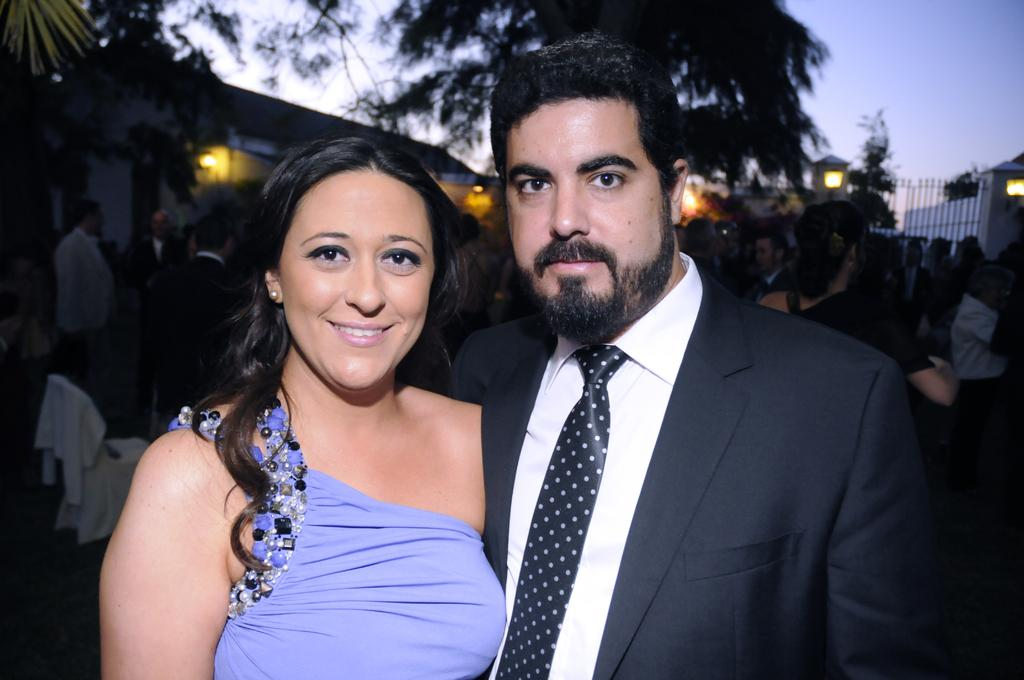Who is present in the image? There is a man and a woman in the image. What is the woman doing in the image? The woman is posing for a camera. What is the woman's facial expression in the image? The woman is smiling in the image. What can be seen in the background of the image? There is a group of people, lights, trees, houses, and the sky visible in the background of the image. What type of gold jewelry is the woman wearing in the image? There is no gold jewelry visible on the woman in the image. What message of peace is being conveyed by the man in the image? The image does not depict any message of peace or any actions by the man that would suggest such a message. 